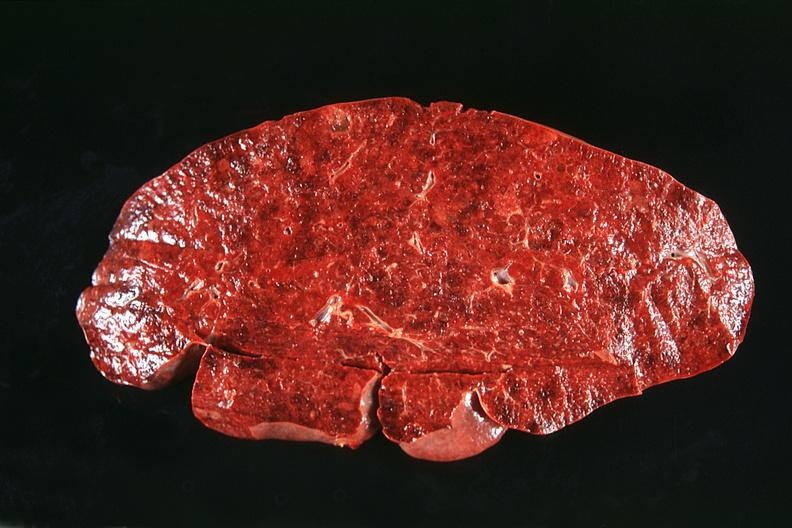s hematologic present?
Answer the question using a single word or phrase. Yes 